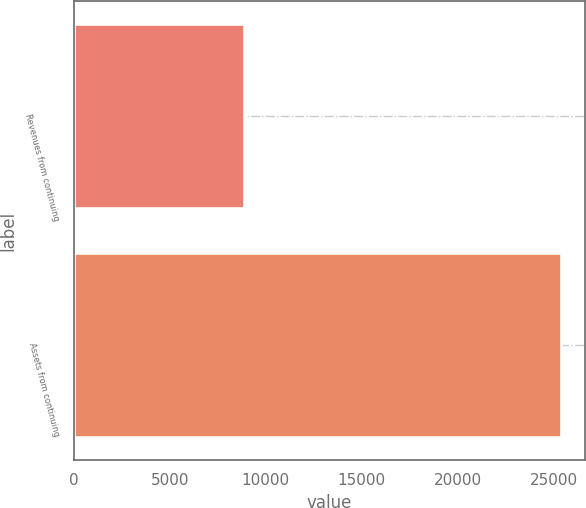Convert chart. <chart><loc_0><loc_0><loc_500><loc_500><bar_chart><fcel>Revenues from continuing<fcel>Assets from continuing<nl><fcel>8867.1<fcel>25351.7<nl></chart> 